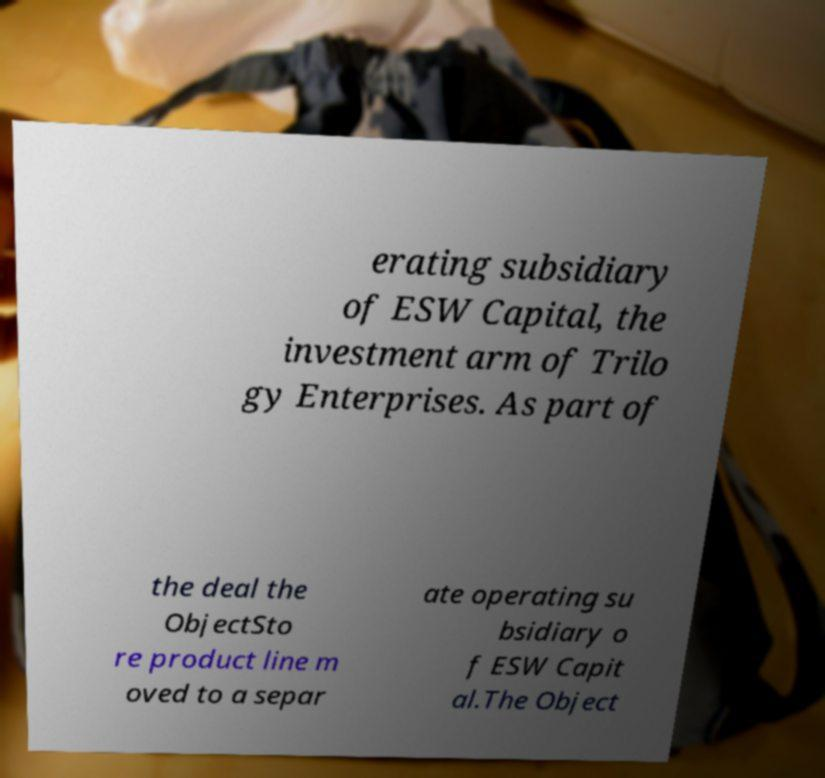Could you extract and type out the text from this image? erating subsidiary of ESW Capital, the investment arm of Trilo gy Enterprises. As part of the deal the ObjectSto re product line m oved to a separ ate operating su bsidiary o f ESW Capit al.The Object 